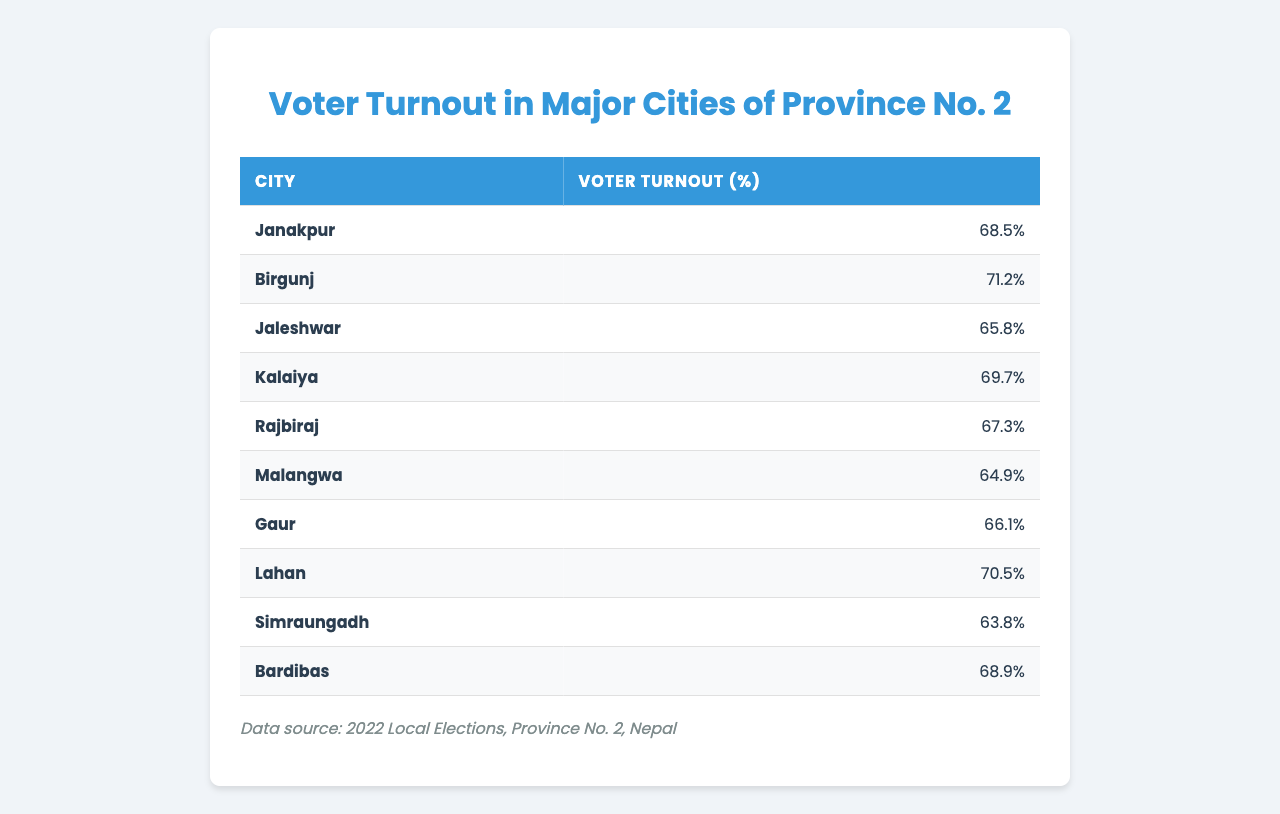What is the voter turnout percentage in Janakpur? The table lists Janakpur with a voter turnout percentage of 68.5%.
Answer: 68.5% Which city had the highest voter turnout? By examining the percentages, Birgunj has the highest voter turnout at 71.2%.
Answer: Birgunj What is the voter turnout percentage for Malangwa? The table shows that Malangwa has a voter turnout of 64.9%.
Answer: 64.9% Calculate the average voter turnout of the cities listed in the table. The sum of the voter turnout percentages is 68.5 + 71.2 + 65.8 + 69.7 + 67.3 + 64.9 + 66.1 + 70.5 + 63.8 + 68.9 =  688.7. There are 10 cities, so the average is 688.7 / 10 = 68.87%.
Answer: 68.87% Is the voter turnout in Lahan higher than that in Rajbiraj? Lahan has a turnout of 70.5%, while Rajbiraj has 67.3%. Thus, Lahan's turnout is higher.
Answer: Yes Which two cities have the lowest voter turnout percentages? The table indicates that Simraungadh has 63.8% and Malangwa has 64.9%, making them the lowest.
Answer: Simraungadh and Malangwa How much higher is the voter turnout in Birgunj compared to Simraungadh? Birgunj has a turnout of 71.2%, while Simraungadh has 63.8%. The difference is 71.2 - 63.8 = 7.4%.
Answer: 7.4% If we combine the voter turnout percentages of Jaleshwar and Gaur, what would that be? Jaleshwar has 65.8% and Gaur has 66.1%, totaling 65.8 + 66.1 = 131.9%.
Answer: 131.9% Are there any cities with a voter turnout of more than 70%? According to the table, only Birgunj and Lahan have turnouts above 70%, specifically 71.2% and 70.5%.
Answer: Yes What percentage gap exists between the highest and lowest voter turnout percentages? The highest is Birgunj at 71.2%, and the lowest is Simraungadh at 63.8%. The gap is 71.2 - 63.8 = 7.4%.
Answer: 7.4% 